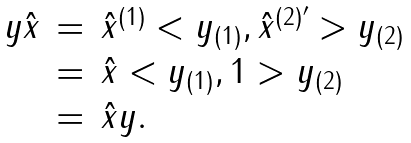<formula> <loc_0><loc_0><loc_500><loc_500>\begin{array} { r c l } y \hat { x } & = & \hat { x } ^ { ( 1 ) } < y _ { ( 1 ) } , \hat { x } ^ { ( 2 ) ^ { \prime } } > y _ { ( 2 ) } \\ & = & \hat { x } < y _ { ( 1 ) } , 1 > y _ { ( 2 ) } \\ & = & \hat { x } y . \end{array}</formula> 